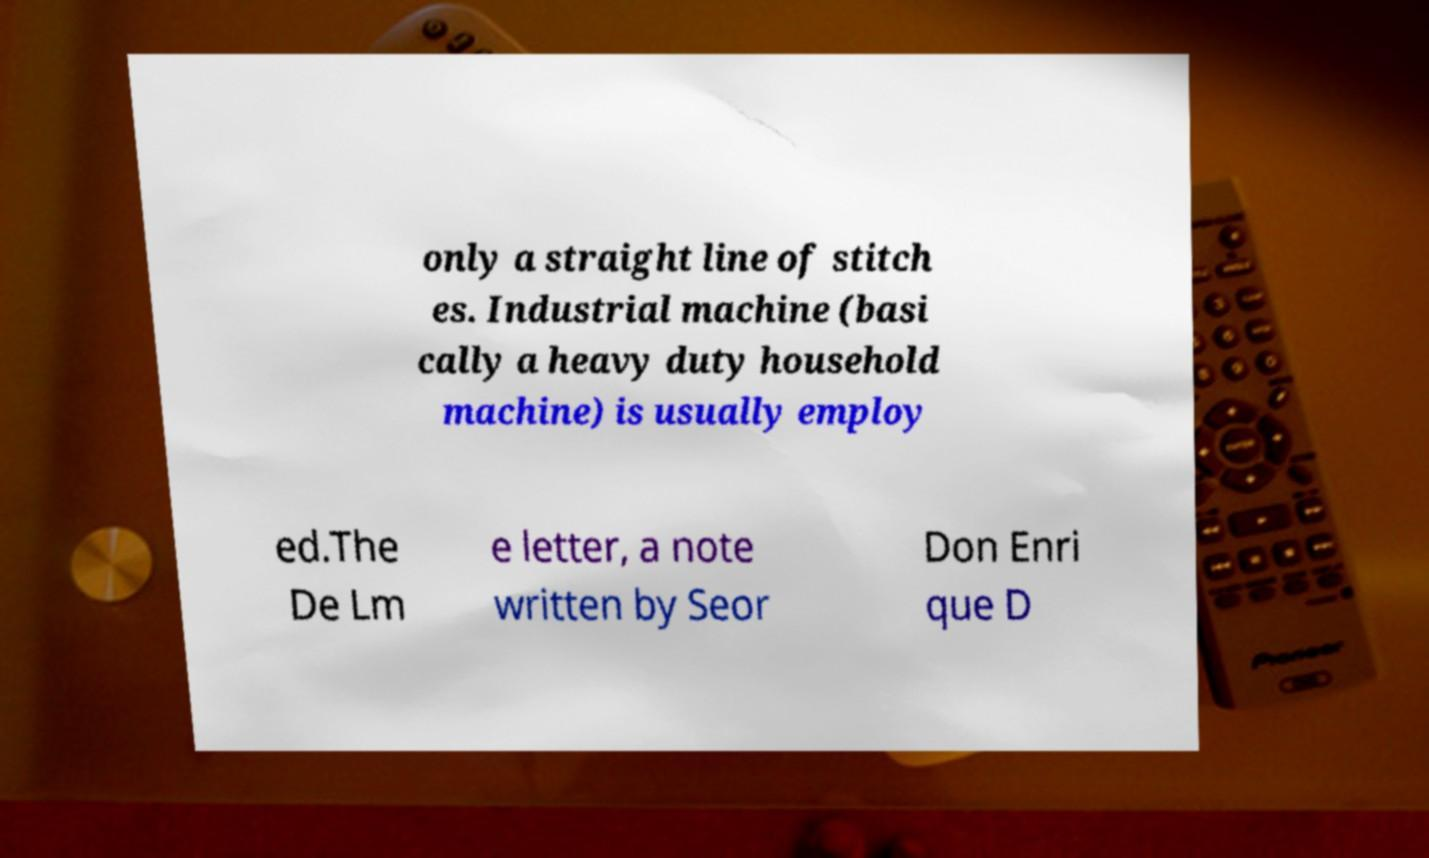Could you assist in decoding the text presented in this image and type it out clearly? only a straight line of stitch es. Industrial machine (basi cally a heavy duty household machine) is usually employ ed.The De Lm e letter, a note written by Seor Don Enri que D 